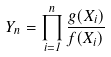<formula> <loc_0><loc_0><loc_500><loc_500>Y _ { n } = \prod _ { i = 1 } ^ { n } \frac { g ( X _ { i } ) } { f ( X _ { i } ) }</formula> 